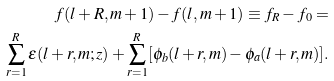Convert formula to latex. <formula><loc_0><loc_0><loc_500><loc_500>f ( l + R , m + 1 ) - f ( l , m + 1 ) \equiv f _ { R } - f _ { 0 } = \\ \sum _ { r = 1 } ^ { R } \epsilon ( l + r , m ; z ) + \sum _ { r = 1 } ^ { R } [ \phi _ { b } ( l + r , m ) - \phi _ { a } ( l + r , m ) ] .</formula> 